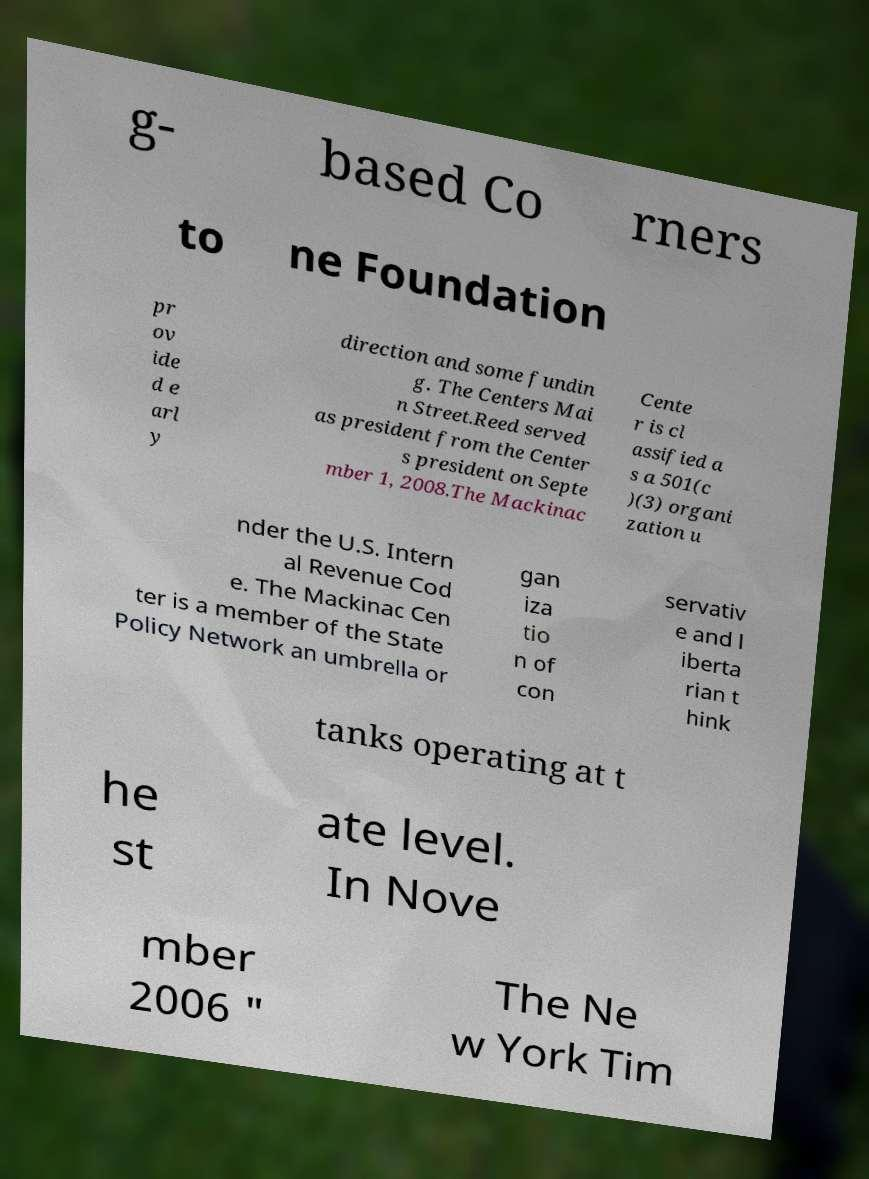I need the written content from this picture converted into text. Can you do that? g- based Co rners to ne Foundation pr ov ide d e arl y direction and some fundin g. The Centers Mai n Street.Reed served as president from the Center s president on Septe mber 1, 2008.The Mackinac Cente r is cl assified a s a 501(c )(3) organi zation u nder the U.S. Intern al Revenue Cod e. The Mackinac Cen ter is a member of the State Policy Network an umbrella or gan iza tio n of con servativ e and l iberta rian t hink tanks operating at t he st ate level. In Nove mber 2006 " The Ne w York Tim 